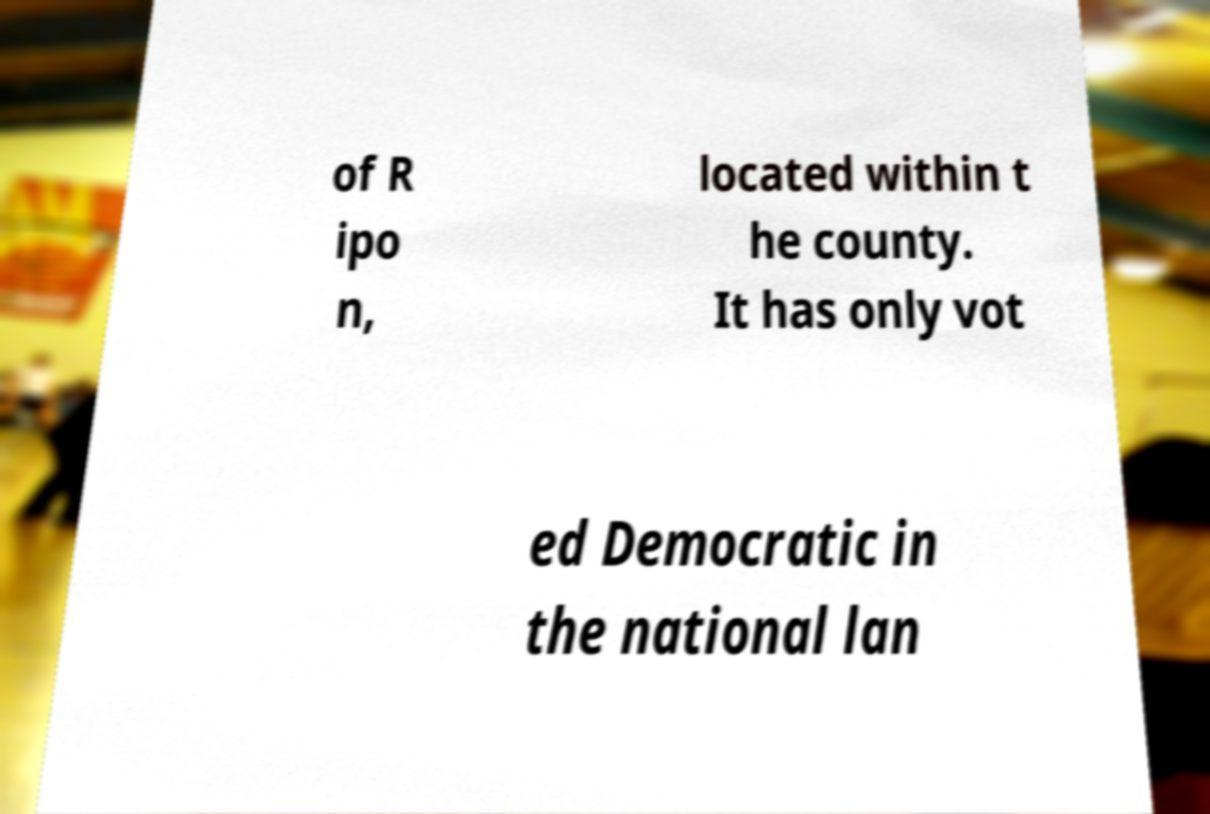Please identify and transcribe the text found in this image. of R ipo n, located within t he county. It has only vot ed Democratic in the national lan 